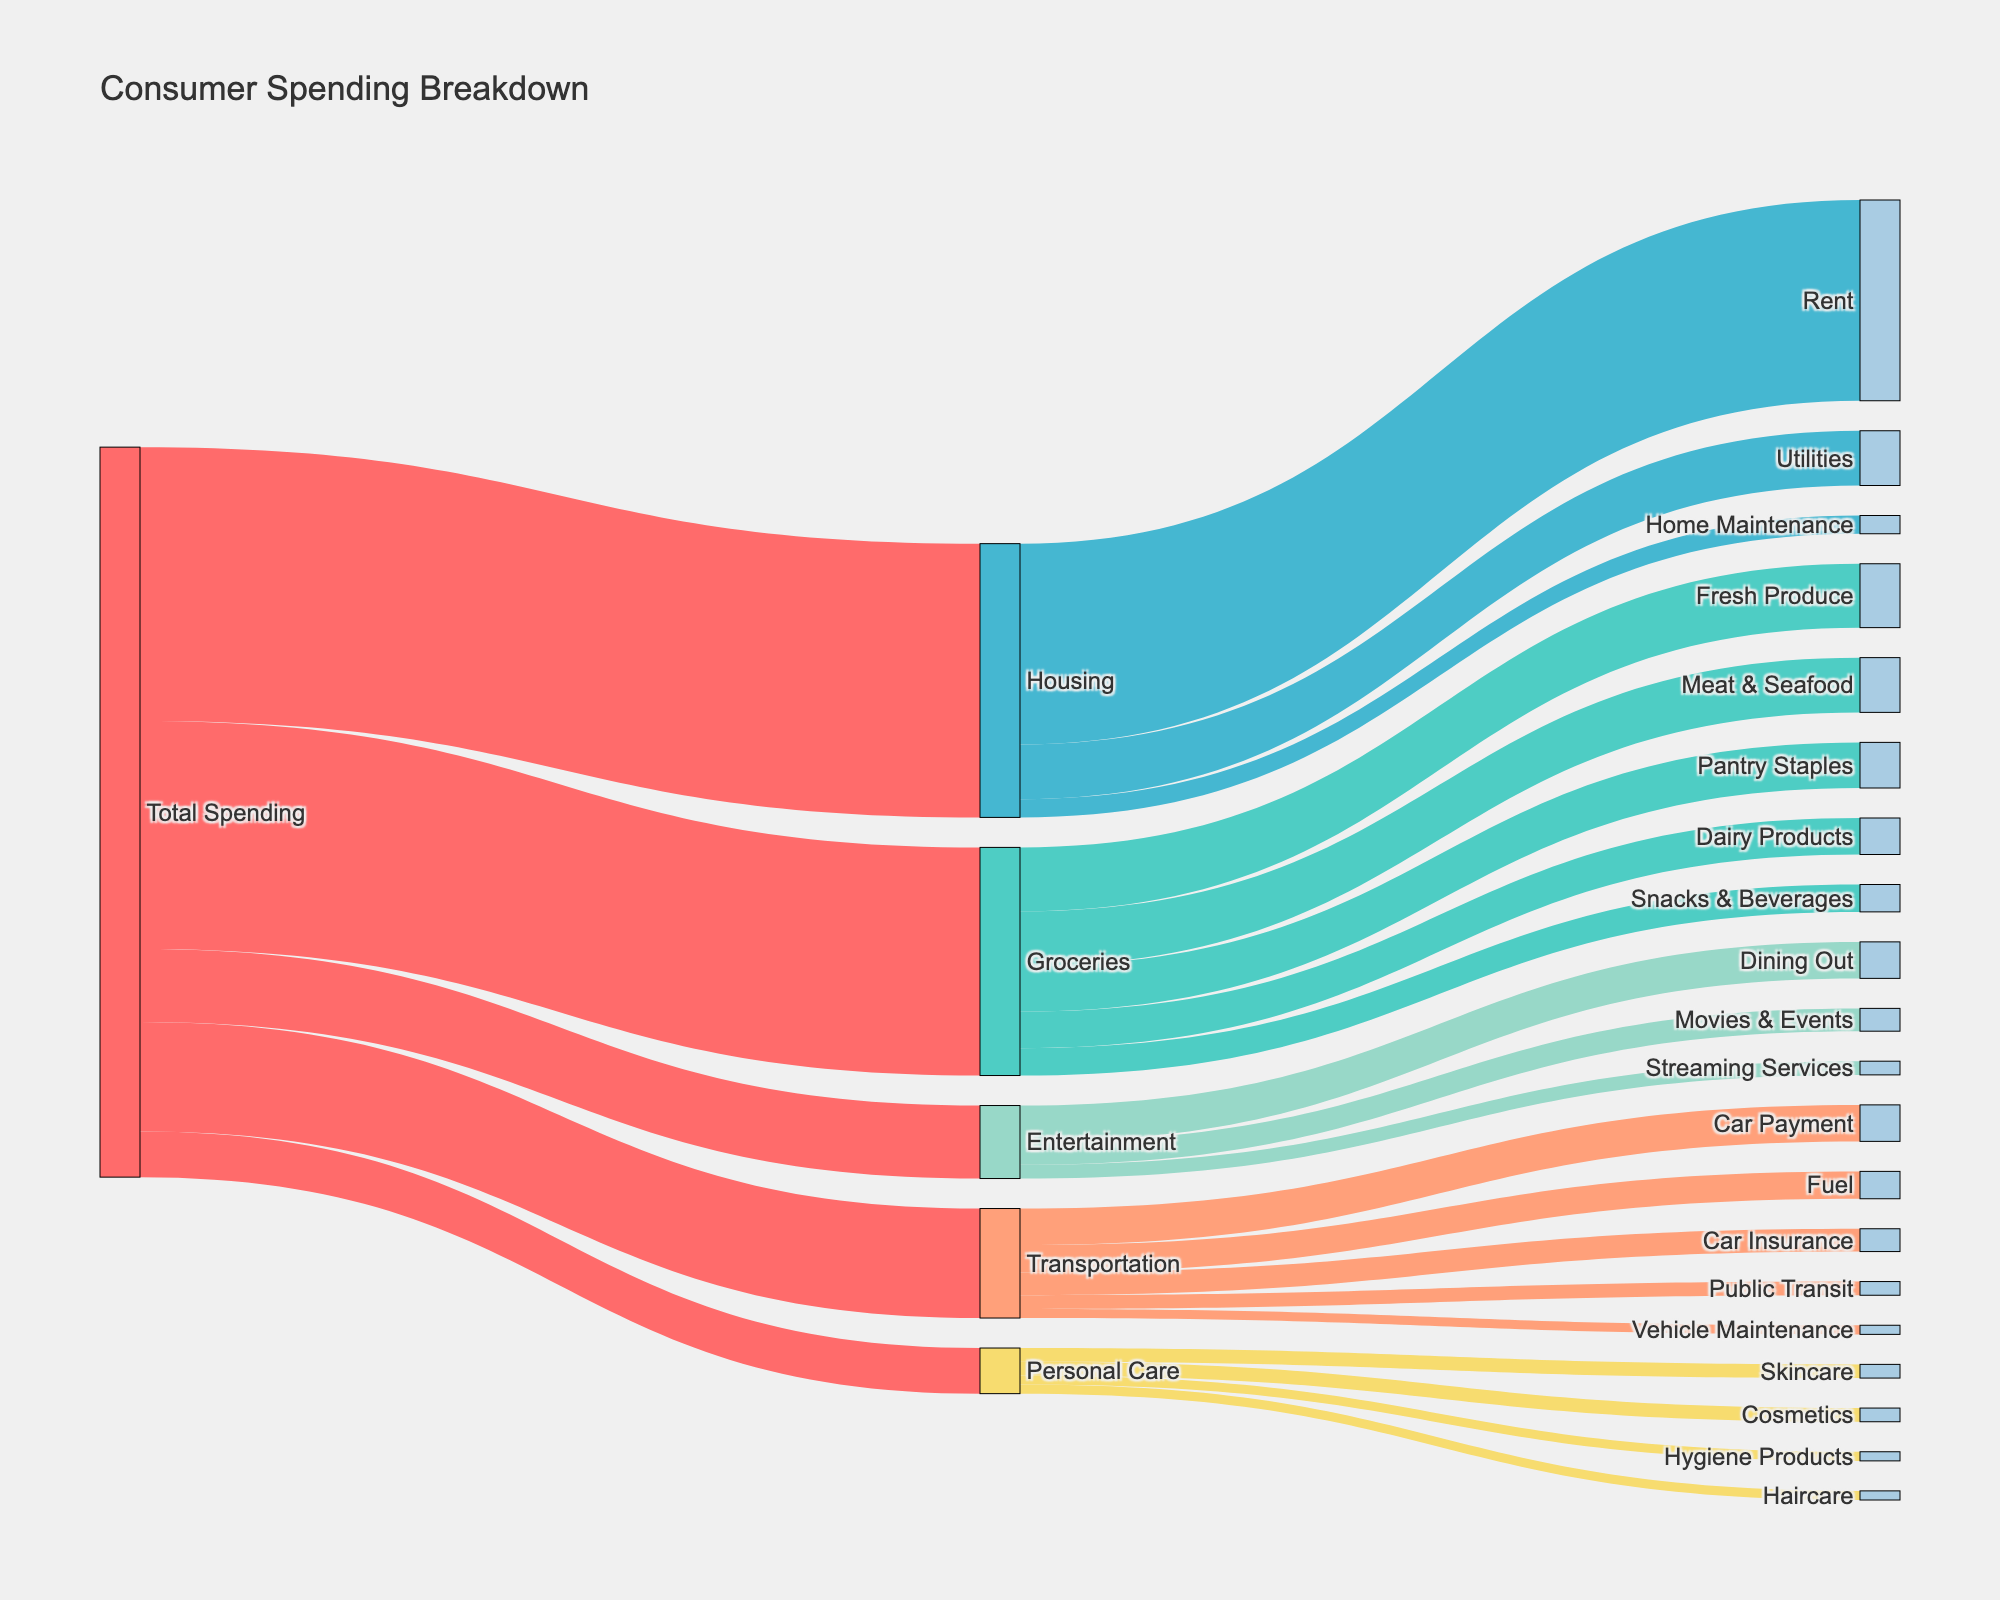what's the title of the figure? The title of the figure is located at the top and usually in larger font size compared to other texts in the diagram.
Answer: Consumer Spending Breakdown how many categories are directly originating from 'Total Spending'? Observe the number of direct links coming out from 'Total Spending' leading to other nodes. Each link represents a different spending category.
Answer: 5 which product subcategory under 'Groceries' has the highest spending? Check the subcategories branching out from 'Groceries' and compare their values to identify the highest one.
Answer: Fresh Produce how does spending on 'Entertainment' compare to 'Personal Care'? Look at the values connected to 'Entertainment' and 'Personal Care' from 'Total Spending' and compare them.
Answer: More on Entertainment what is the combined spending on 'Rent' and 'Utilities' under 'Housing'? Sum the values for 'Rent' and 'Utilities', which are subcategories under 'Housing'.
Answer: 2800 which is the smallest subcategory under 'Transportation'? Observe all subcategories branching out from 'Transportation' and note the one with the smallest value.
Answer: Vehicle Maintenance how much more is spent on 'Movies & Events' compared to 'Cosmetics'? Find the spending values for 'Movies & Events' and 'Cosmetics', then subtract the latter from the former.
Answer: 100 what's the total consumption on subcategories of 'Personal Care'? Add up the spending values of all subcategories under 'Personal Care'.
Answer: 500 are 'Snacks & Beverages' a larger expense than 'Home Maintenance'? Compare the values associated with 'Snacks & Beverages' and 'Home Maintenance'.
Answer: No what percentage of 'Total Spending' is spent on 'Housing'? Divide the spending value of 'Housing' by 'Total Spending' value and multiply by 100 to get the percentage.
Answer: 30% 